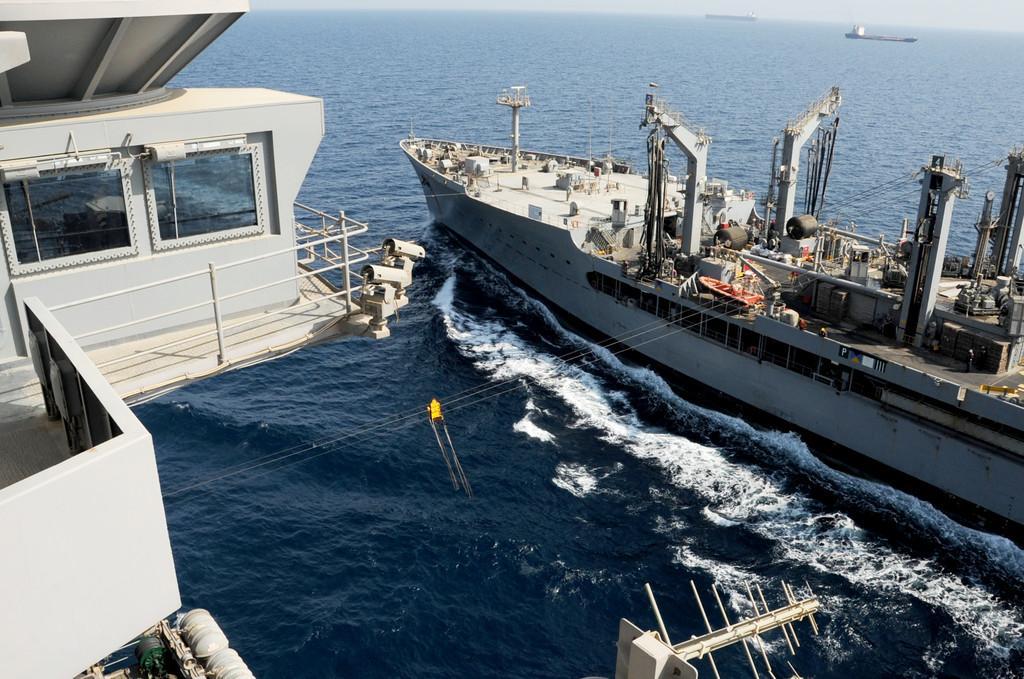Please provide a concise description of this image. In this picture I can observe a ship floating on the water. In the background there is an ocean. I can observe two ships floating on the water. 